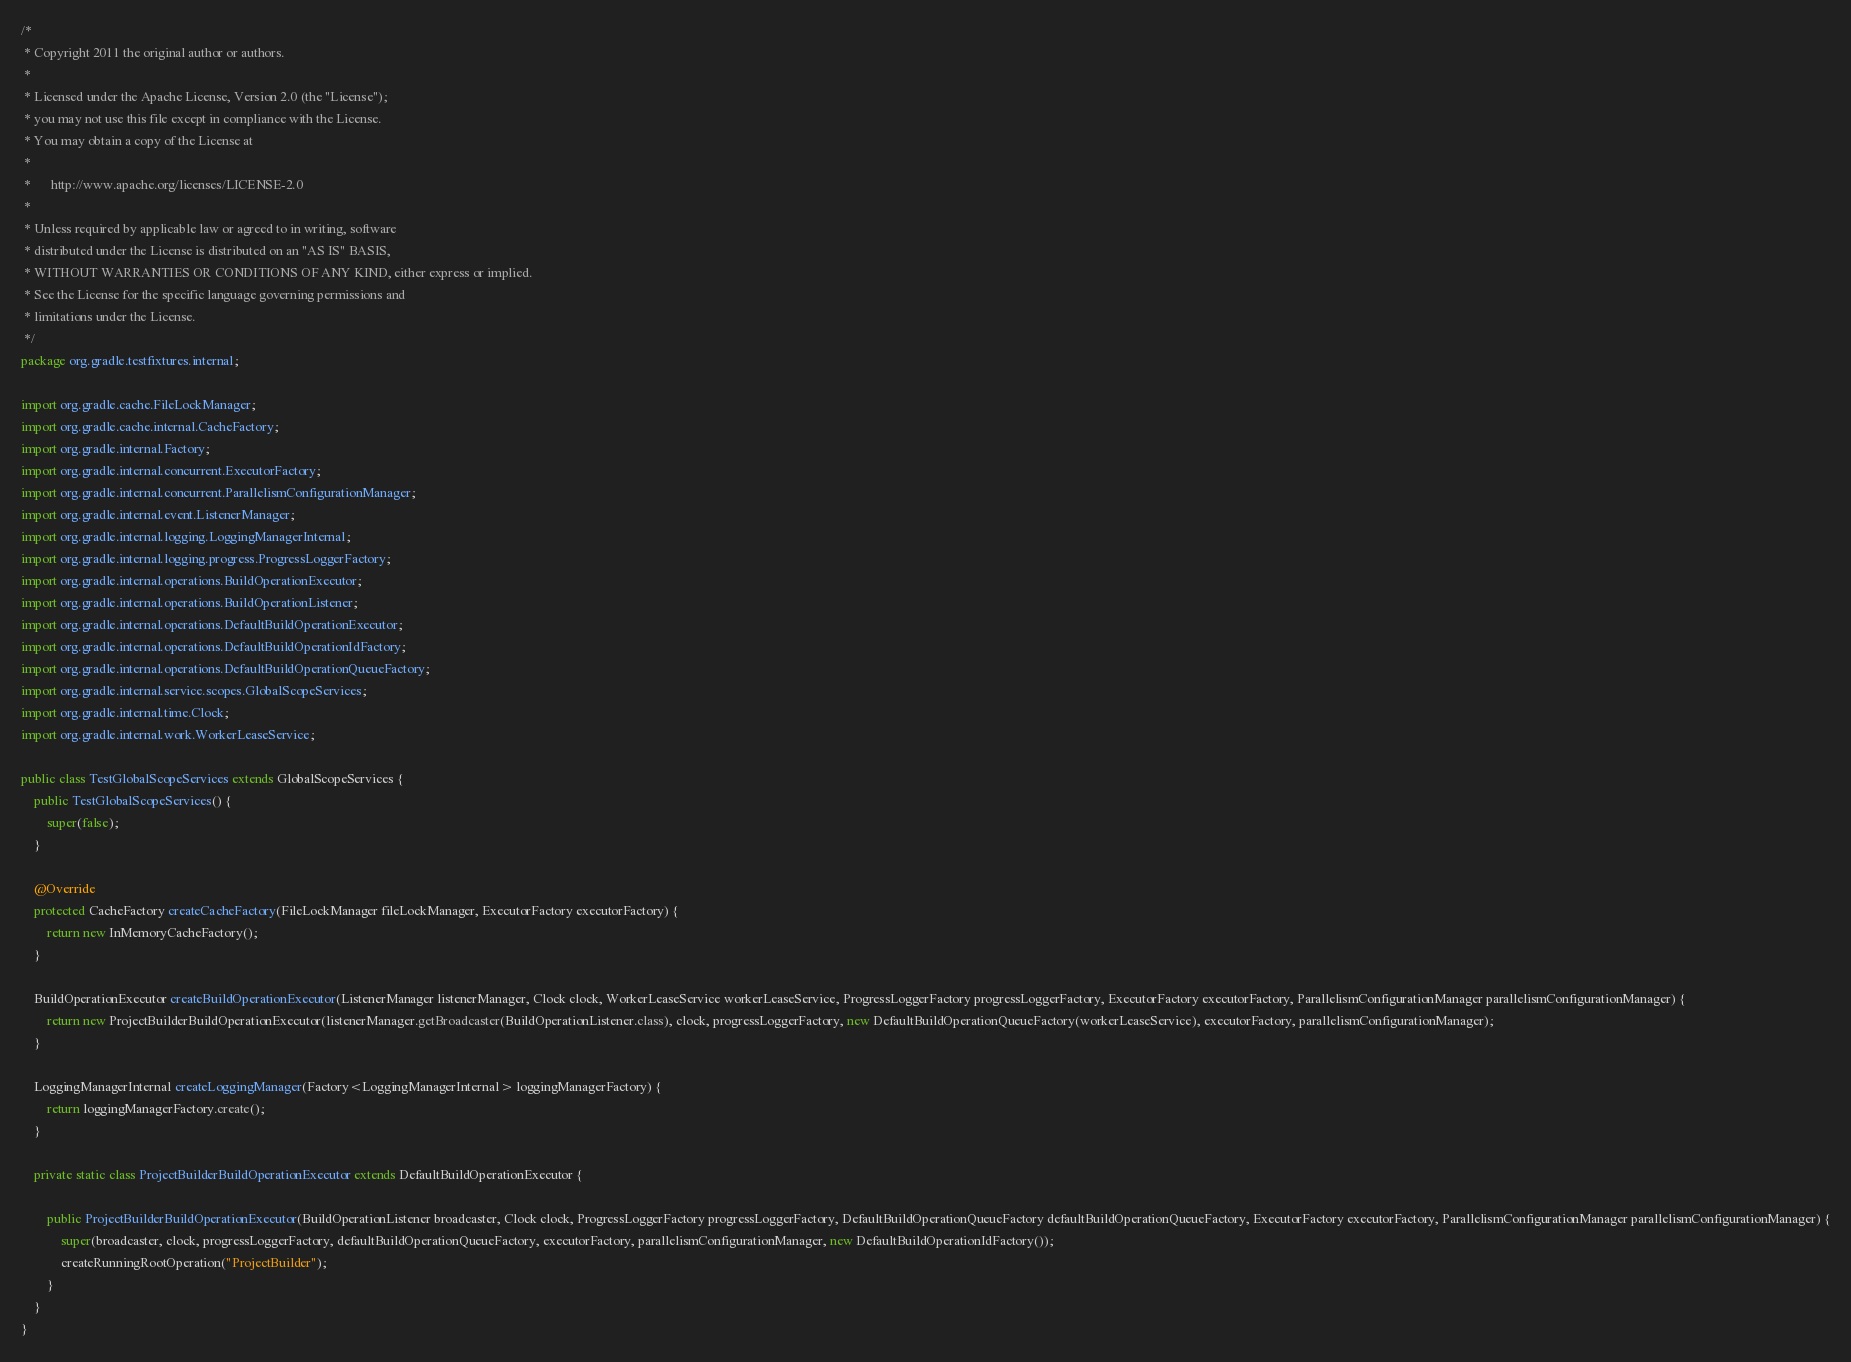<code> <loc_0><loc_0><loc_500><loc_500><_Java_>/*
 * Copyright 2011 the original author or authors.
 *
 * Licensed under the Apache License, Version 2.0 (the "License");
 * you may not use this file except in compliance with the License.
 * You may obtain a copy of the License at
 *
 *      http://www.apache.org/licenses/LICENSE-2.0
 *
 * Unless required by applicable law or agreed to in writing, software
 * distributed under the License is distributed on an "AS IS" BASIS,
 * WITHOUT WARRANTIES OR CONDITIONS OF ANY KIND, either express or implied.
 * See the License for the specific language governing permissions and
 * limitations under the License.
 */
package org.gradle.testfixtures.internal;

import org.gradle.cache.FileLockManager;
import org.gradle.cache.internal.CacheFactory;
import org.gradle.internal.Factory;
import org.gradle.internal.concurrent.ExecutorFactory;
import org.gradle.internal.concurrent.ParallelismConfigurationManager;
import org.gradle.internal.event.ListenerManager;
import org.gradle.internal.logging.LoggingManagerInternal;
import org.gradle.internal.logging.progress.ProgressLoggerFactory;
import org.gradle.internal.operations.BuildOperationExecutor;
import org.gradle.internal.operations.BuildOperationListener;
import org.gradle.internal.operations.DefaultBuildOperationExecutor;
import org.gradle.internal.operations.DefaultBuildOperationIdFactory;
import org.gradle.internal.operations.DefaultBuildOperationQueueFactory;
import org.gradle.internal.service.scopes.GlobalScopeServices;
import org.gradle.internal.time.Clock;
import org.gradle.internal.work.WorkerLeaseService;

public class TestGlobalScopeServices extends GlobalScopeServices {
    public TestGlobalScopeServices() {
        super(false);
    }

    @Override
    protected CacheFactory createCacheFactory(FileLockManager fileLockManager, ExecutorFactory executorFactory) {
        return new InMemoryCacheFactory();
    }

    BuildOperationExecutor createBuildOperationExecutor(ListenerManager listenerManager, Clock clock, WorkerLeaseService workerLeaseService, ProgressLoggerFactory progressLoggerFactory, ExecutorFactory executorFactory, ParallelismConfigurationManager parallelismConfigurationManager) {
        return new ProjectBuilderBuildOperationExecutor(listenerManager.getBroadcaster(BuildOperationListener.class), clock, progressLoggerFactory, new DefaultBuildOperationQueueFactory(workerLeaseService), executorFactory, parallelismConfigurationManager);
    }

    LoggingManagerInternal createLoggingManager(Factory<LoggingManagerInternal> loggingManagerFactory) {
        return loggingManagerFactory.create();
    }

    private static class ProjectBuilderBuildOperationExecutor extends DefaultBuildOperationExecutor {

        public ProjectBuilderBuildOperationExecutor(BuildOperationListener broadcaster, Clock clock, ProgressLoggerFactory progressLoggerFactory, DefaultBuildOperationQueueFactory defaultBuildOperationQueueFactory, ExecutorFactory executorFactory, ParallelismConfigurationManager parallelismConfigurationManager) {
            super(broadcaster, clock, progressLoggerFactory, defaultBuildOperationQueueFactory, executorFactory, parallelismConfigurationManager, new DefaultBuildOperationIdFactory());
            createRunningRootOperation("ProjectBuilder");
        }
    }
}
</code> 